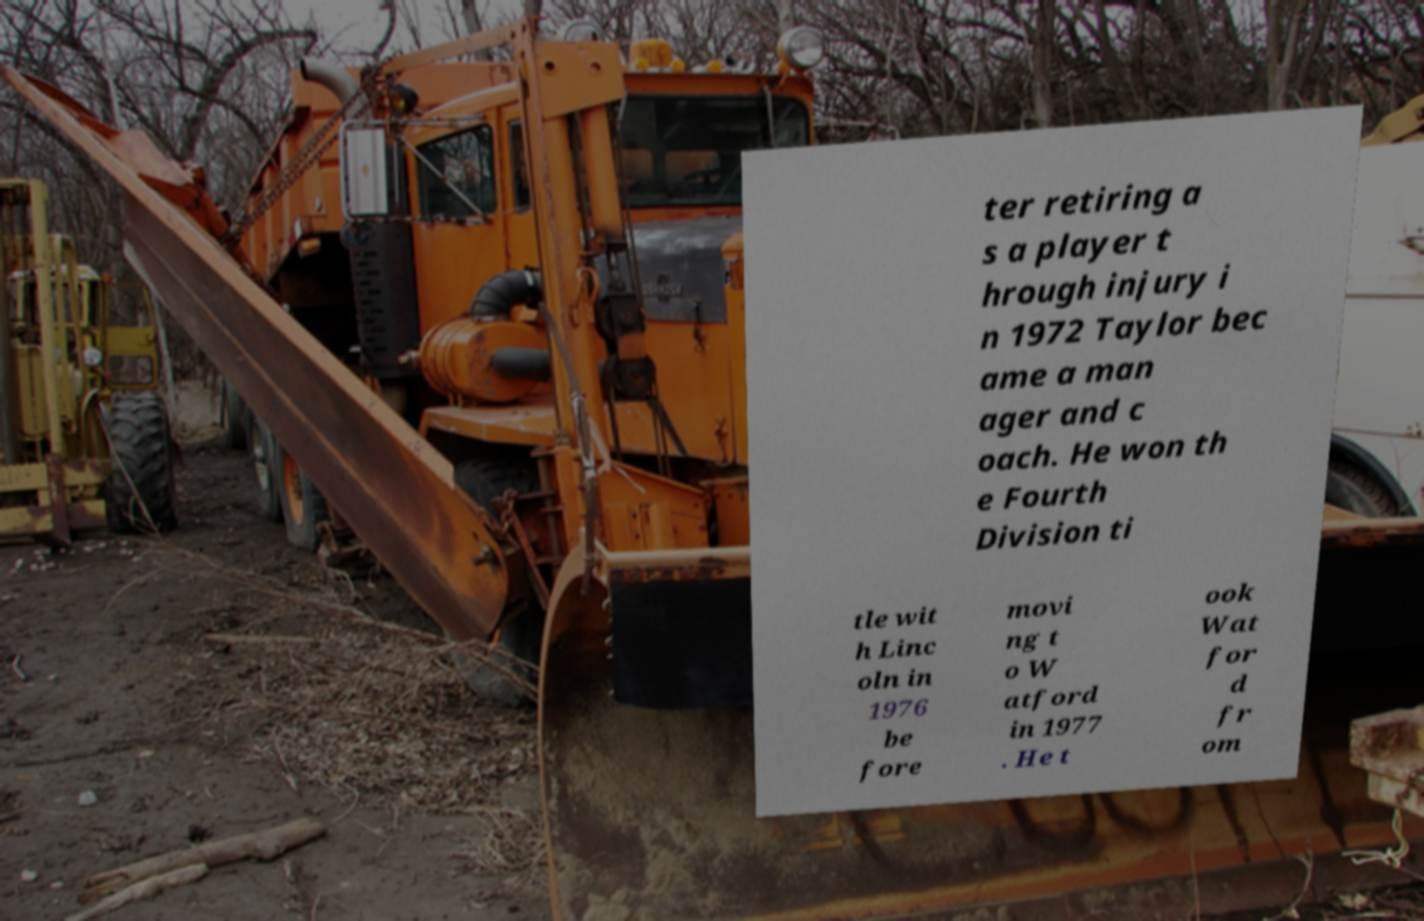There's text embedded in this image that I need extracted. Can you transcribe it verbatim? ter retiring a s a player t hrough injury i n 1972 Taylor bec ame a man ager and c oach. He won th e Fourth Division ti tle wit h Linc oln in 1976 be fore movi ng t o W atford in 1977 . He t ook Wat for d fr om 